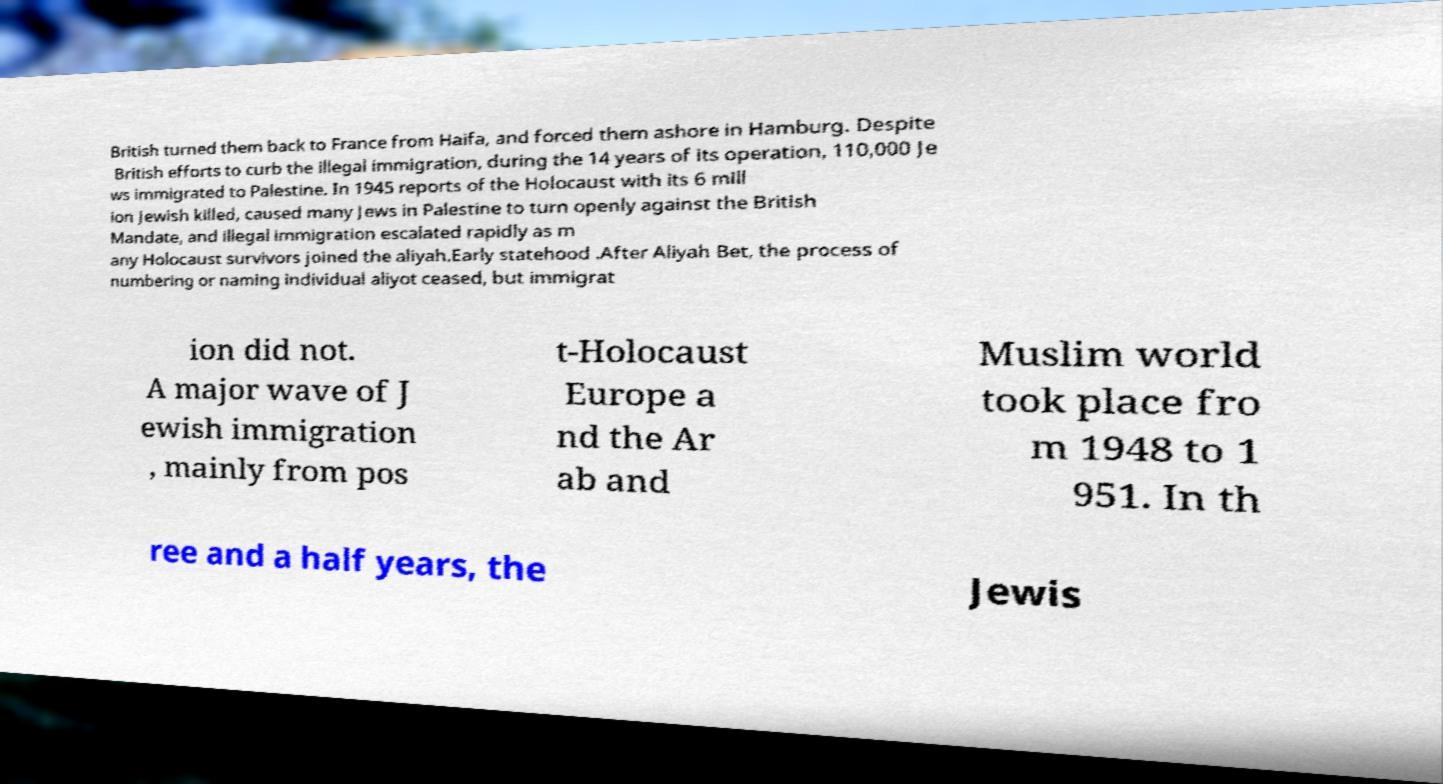Please read and relay the text visible in this image. What does it say? British turned them back to France from Haifa, and forced them ashore in Hamburg. Despite British efforts to curb the illegal immigration, during the 14 years of its operation, 110,000 Je ws immigrated to Palestine. In 1945 reports of the Holocaust with its 6 mill ion Jewish killed, caused many Jews in Palestine to turn openly against the British Mandate, and illegal immigration escalated rapidly as m any Holocaust survivors joined the aliyah.Early statehood .After Aliyah Bet, the process of numbering or naming individual aliyot ceased, but immigrat ion did not. A major wave of J ewish immigration , mainly from pos t-Holocaust Europe a nd the Ar ab and Muslim world took place fro m 1948 to 1 951. In th ree and a half years, the Jewis 